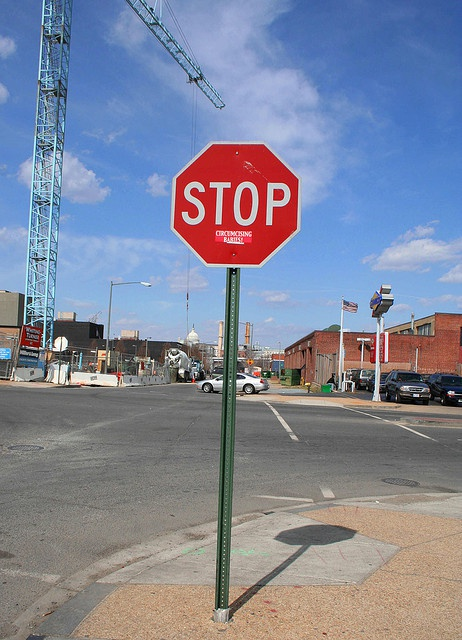Describe the objects in this image and their specific colors. I can see stop sign in gray, brown, lightgray, and darkgray tones, car in gray, black, and blue tones, car in gray, white, darkgray, and black tones, truck in gray, black, navy, and blue tones, and truck in gray, darkgray, black, and lightgray tones in this image. 